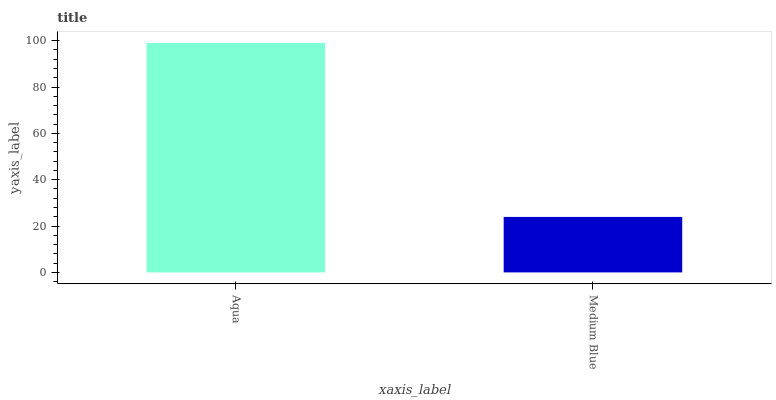Is Medium Blue the minimum?
Answer yes or no. Yes. Is Aqua the maximum?
Answer yes or no. Yes. Is Medium Blue the maximum?
Answer yes or no. No. Is Aqua greater than Medium Blue?
Answer yes or no. Yes. Is Medium Blue less than Aqua?
Answer yes or no. Yes. Is Medium Blue greater than Aqua?
Answer yes or no. No. Is Aqua less than Medium Blue?
Answer yes or no. No. Is Aqua the high median?
Answer yes or no. Yes. Is Medium Blue the low median?
Answer yes or no. Yes. Is Medium Blue the high median?
Answer yes or no. No. Is Aqua the low median?
Answer yes or no. No. 